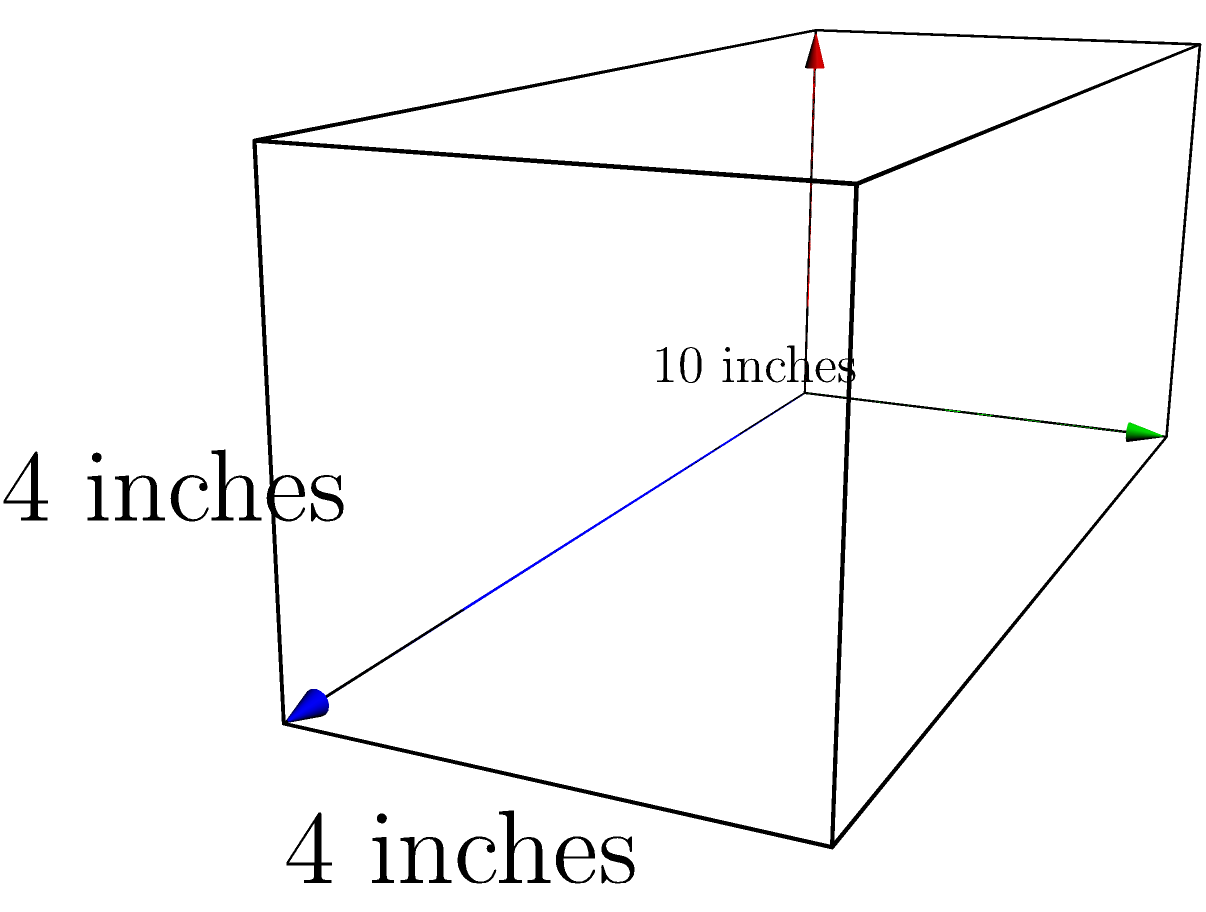You've just finished your first 5K race and want to use a foam roller for recovery. The rectangular prism-shaped foam roller you're considering has dimensions of 10 inches in length, 4 inches in width, and 4 inches in height. What is the volume of this foam roller in cubic inches? To find the volume of a rectangular prism, we need to multiply its length, width, and height.

Given:
- Length = 10 inches
- Width = 4 inches
- Height = 4 inches

Step 1: Apply the formula for the volume of a rectangular prism.
Volume = Length × Width × Height

Step 2: Substitute the given values into the formula.
Volume = 10 inches × 4 inches × 4 inches

Step 3: Multiply the numbers.
Volume = 160 cubic inches

Therefore, the volume of the foam roller is 160 cubic inches.
Answer: 160 cubic inches 